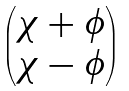<formula> <loc_0><loc_0><loc_500><loc_500>\begin{pmatrix} \chi + \phi \\ \chi - \phi \end{pmatrix}</formula> 